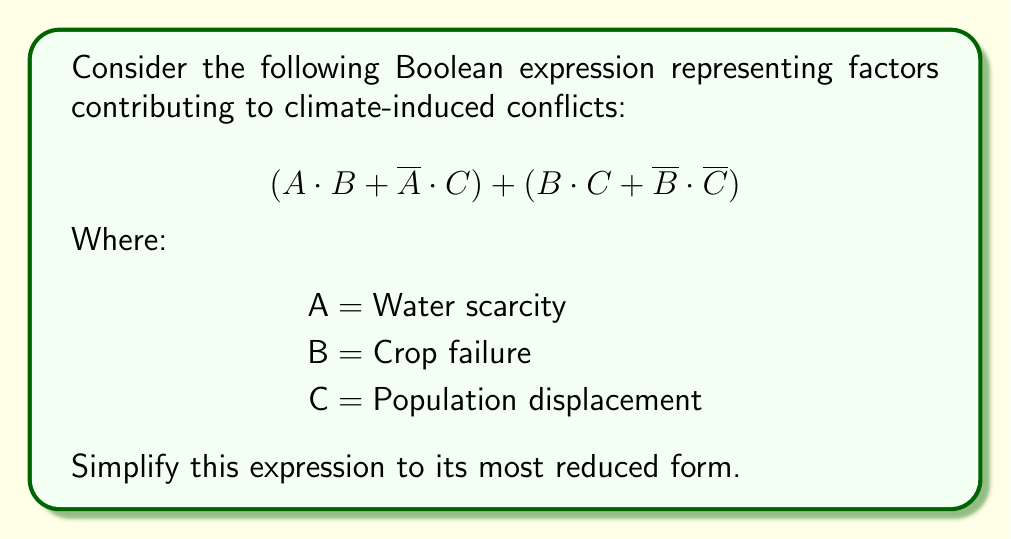Solve this math problem. Let's simplify this Boolean expression step-by-step:

1) First, let's distribute the OR operation over the two main terms:
   $$(A \cdot B + \overline{A} \cdot C) + (B \cdot C + \overline{B} \cdot \overline{C})$$

2) Now, let's focus on the first term $(A \cdot B + \overline{A} \cdot C)$:
   This is in the form of a multiplexer $(X \cdot Y + \overline{X} \cdot Z)$, which simplifies to $(Y + Z)$ when $X$ is true, and $(Z)$ when $X$ is false. Therefore, it can be written as:
   $$(B + C)$$

3) For the second term $(B \cdot C + \overline{B} \cdot \overline{C})$:
   This is the exclusive NOR (XNOR) of B and C, which is equivalent to:
   $$(B \equiv C)$$

4) Now our expression looks like:
   $$(B + C) + (B \equiv C)$$

5) Expanding $(B \equiv C)$:
   $$(B + C) + (B \cdot C + \overline{B} \cdot \overline{C})$$

6) Distributing the OR operation:
   $$B + C + B \cdot C + \overline{B} \cdot \overline{C}$$

7) Using the absorption law, $B + B \cdot C = B$:
   $$B + C + \overline{B} \cdot \overline{C}$$

8) This is the final simplified form. It cannot be reduced further.

This simplified expression shows that climate-induced conflicts are likely when there's crop failure (B) OR population displacement (C) OR when neither crop failure NOR population displacement occurs (which could represent other underlying factors).
Answer: $$B + C + \overline{B} \cdot \overline{C}$$ 